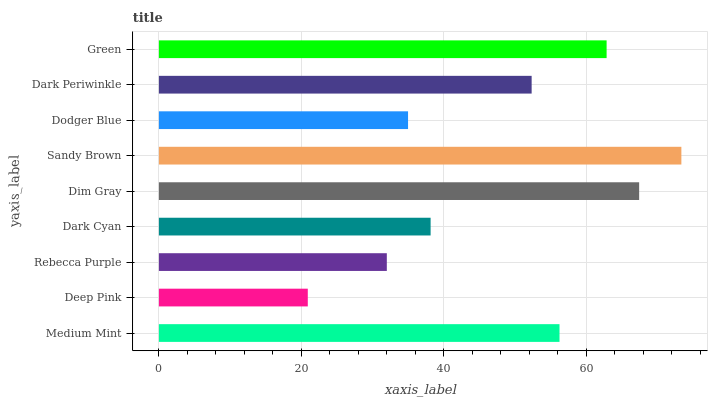Is Deep Pink the minimum?
Answer yes or no. Yes. Is Sandy Brown the maximum?
Answer yes or no. Yes. Is Rebecca Purple the minimum?
Answer yes or no. No. Is Rebecca Purple the maximum?
Answer yes or no. No. Is Rebecca Purple greater than Deep Pink?
Answer yes or no. Yes. Is Deep Pink less than Rebecca Purple?
Answer yes or no. Yes. Is Deep Pink greater than Rebecca Purple?
Answer yes or no. No. Is Rebecca Purple less than Deep Pink?
Answer yes or no. No. Is Dark Periwinkle the high median?
Answer yes or no. Yes. Is Dark Periwinkle the low median?
Answer yes or no. Yes. Is Rebecca Purple the high median?
Answer yes or no. No. Is Sandy Brown the low median?
Answer yes or no. No. 